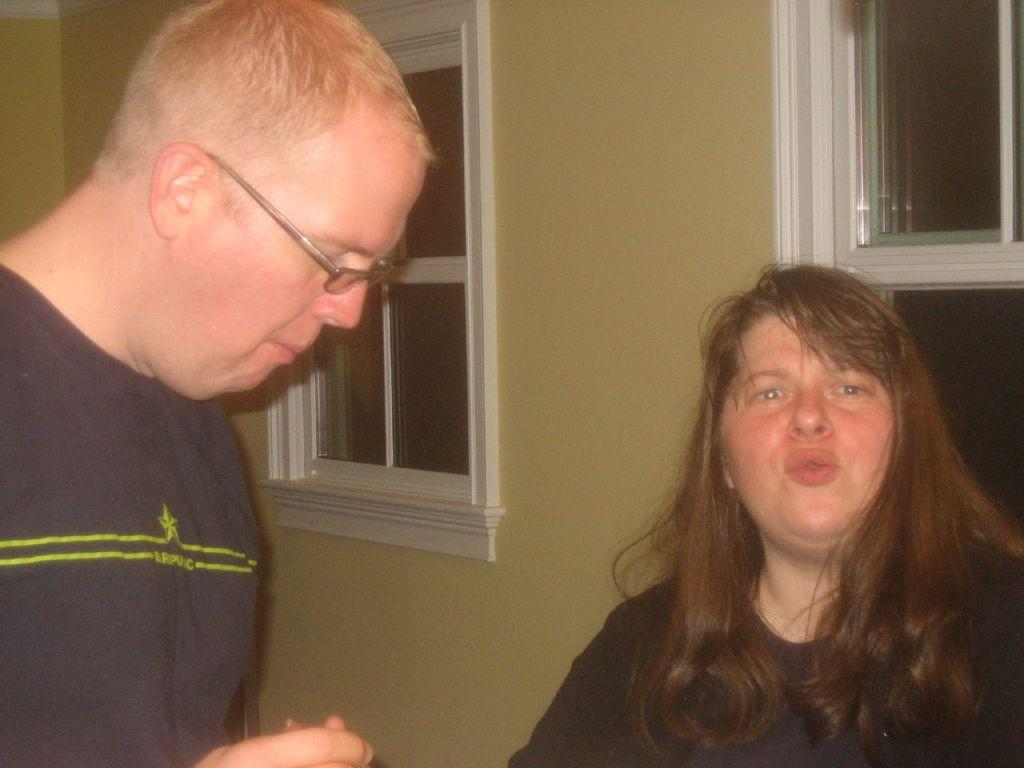How many people are in the image? There are people in the image, but the exact number is not specified. Can you describe any distinguishing features of one of the people? One person is wearing glasses. What is the person wearing glasses doing in the image? The person wearing glasses is holding an object. What can be seen in the background of the image? There are windows and a wall in the background of the image. How many ladybugs are crawling on the bed in the image? There is no bed or ladybugs present in the image. What type of chain is being used by the person holding the object? The person holding the object is not using a chain in the image. 